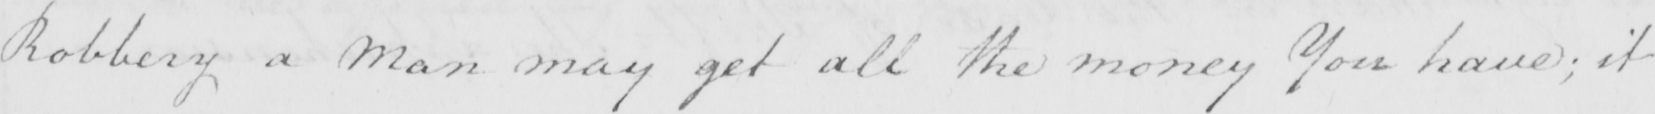Transcribe the text shown in this historical manuscript line. Robbery a Man may get all the money You have ; it 